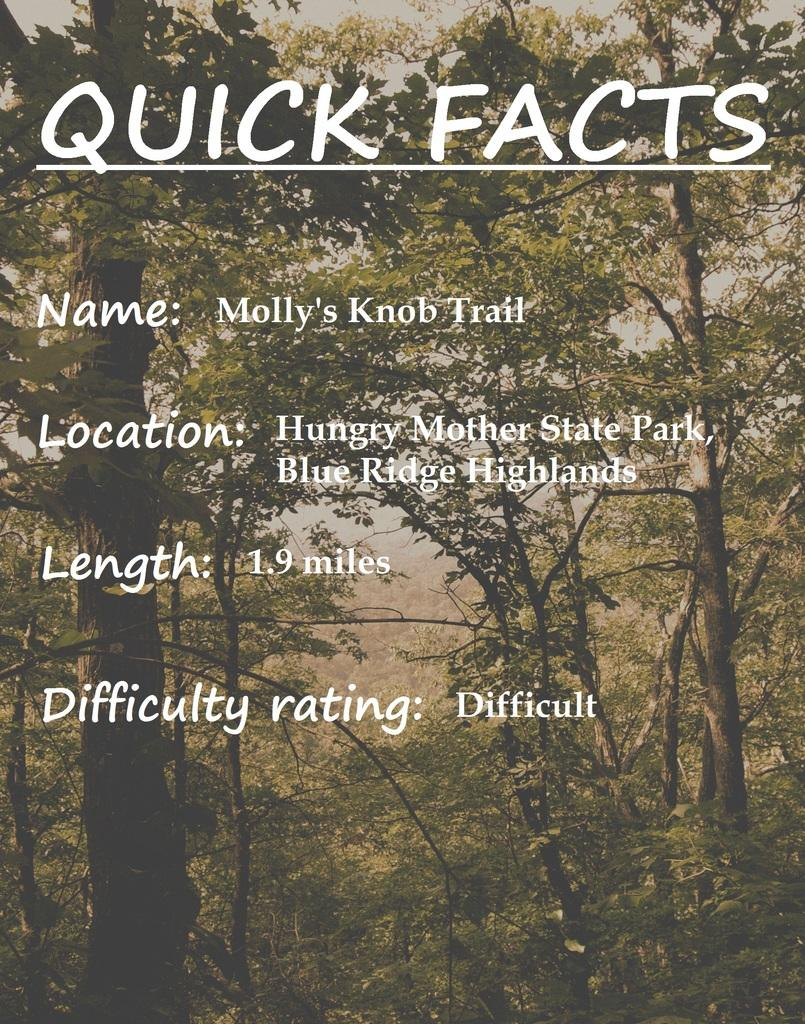<image>
Offer a succinct explanation of the picture presented. Molly's Knob Trail is 1.9 miles and has a high difficulty rating. 